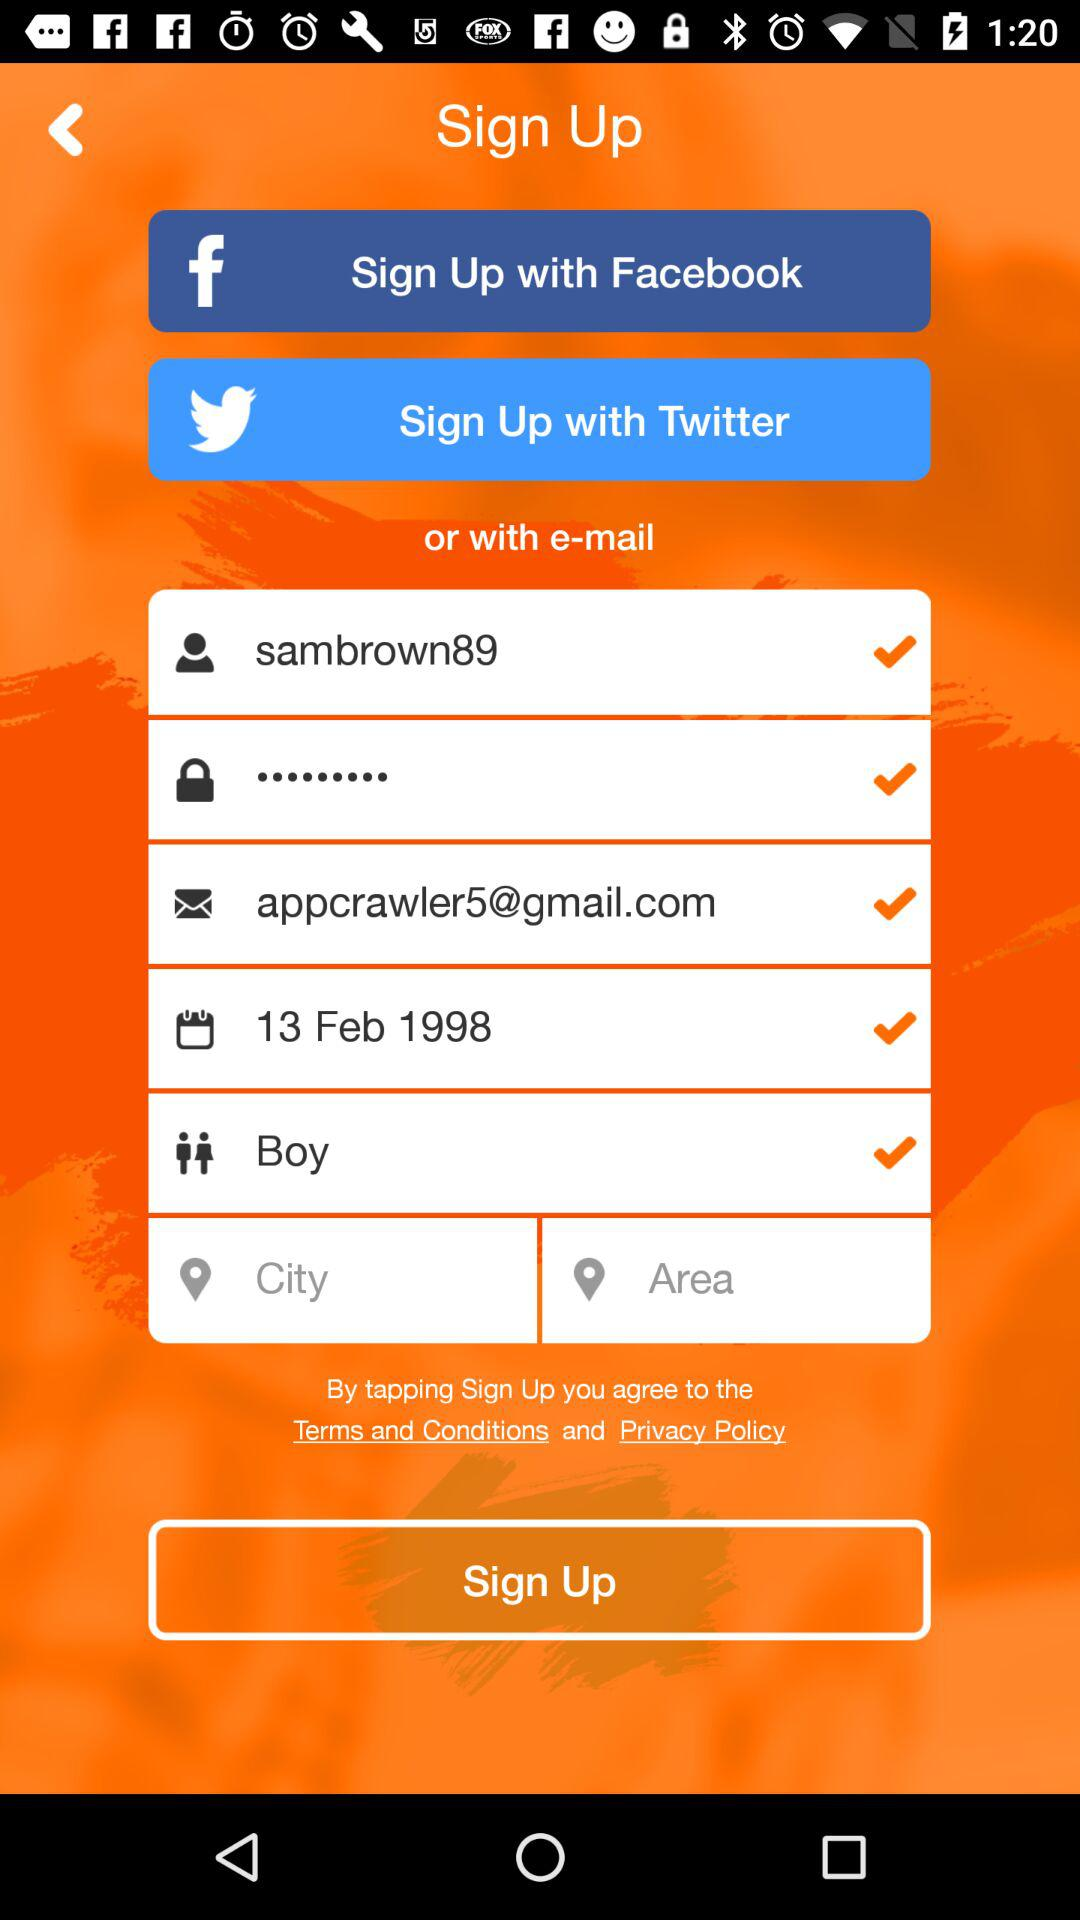What is the username? The username is "sambrown89". 